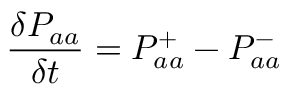Convert formula to latex. <formula><loc_0><loc_0><loc_500><loc_500>\frac { \delta P _ { a a } } { \delta t } = P _ { a a } ^ { + } - P _ { a a } ^ { - }</formula> 